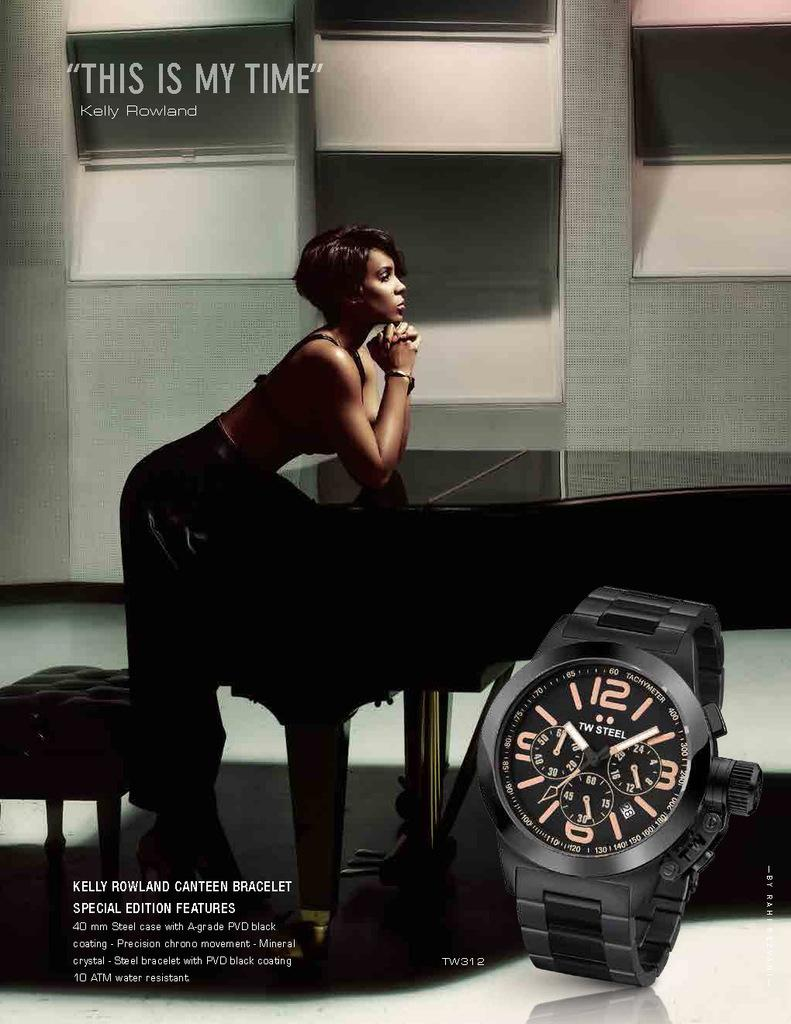Provide a one-sentence caption for the provided image. Kelly Rowland leans on a piano in a sultry advert which features a watch in the forefront. 